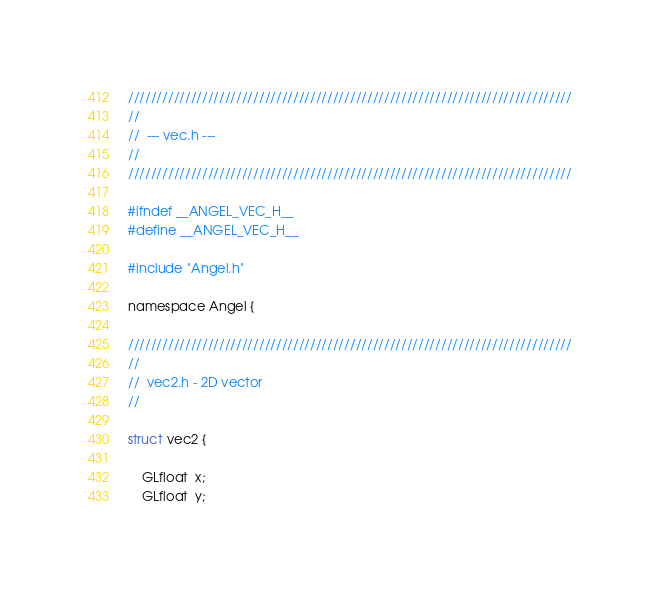<code> <loc_0><loc_0><loc_500><loc_500><_C_>//////////////////////////////////////////////////////////////////////////////
//
//  --- vec.h ---
//
//////////////////////////////////////////////////////////////////////////////

#ifndef __ANGEL_VEC_H__
#define __ANGEL_VEC_H__

#include "Angel.h"

namespace Angel {

//////////////////////////////////////////////////////////////////////////////
//
//  vec2.h - 2D vector
//

struct vec2 {

    GLfloat  x;
    GLfloat  y;
</code> 